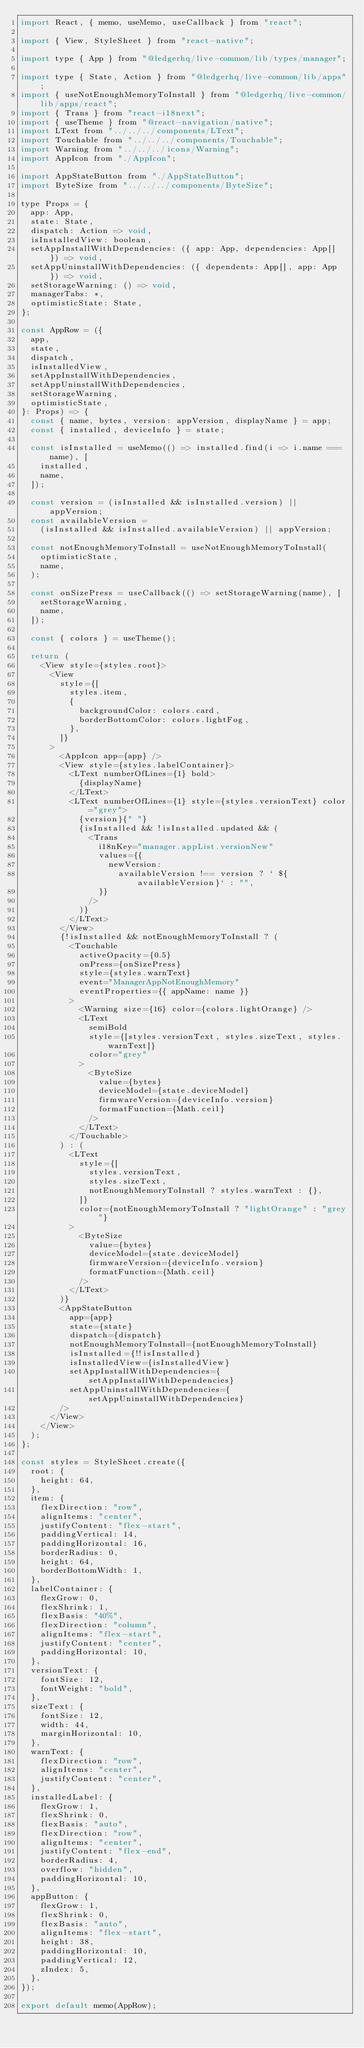Convert code to text. <code><loc_0><loc_0><loc_500><loc_500><_JavaScript_>import React, { memo, useMemo, useCallback } from "react";

import { View, StyleSheet } from "react-native";

import type { App } from "@ledgerhq/live-common/lib/types/manager";

import type { State, Action } from "@ledgerhq/live-common/lib/apps";
import { useNotEnoughMemoryToInstall } from "@ledgerhq/live-common/lib/apps/react";
import { Trans } from "react-i18next";
import { useTheme } from "@react-navigation/native";
import LText from "../../../components/LText";
import Touchable from "../../../components/Touchable";
import Warning from "../../../icons/Warning";
import AppIcon from "./AppIcon";

import AppStateButton from "./AppStateButton";
import ByteSize from "../../../components/ByteSize";

type Props = {
  app: App,
  state: State,
  dispatch: Action => void,
  isInstalledView: boolean,
  setAppInstallWithDependencies: ({ app: App, dependencies: App[] }) => void,
  setAppUninstallWithDependencies: ({ dependents: App[], app: App }) => void,
  setStorageWarning: () => void,
  managerTabs: *,
  optimisticState: State,
};

const AppRow = ({
  app,
  state,
  dispatch,
  isInstalledView,
  setAppInstallWithDependencies,
  setAppUninstallWithDependencies,
  setStorageWarning,
  optimisticState,
}: Props) => {
  const { name, bytes, version: appVersion, displayName } = app;
  const { installed, deviceInfo } = state;

  const isInstalled = useMemo(() => installed.find(i => i.name === name), [
    installed,
    name,
  ]);

  const version = (isInstalled && isInstalled.version) || appVersion;
  const availableVersion =
    (isInstalled && isInstalled.availableVersion) || appVersion;

  const notEnoughMemoryToInstall = useNotEnoughMemoryToInstall(
    optimisticState,
    name,
  );

  const onSizePress = useCallback(() => setStorageWarning(name), [
    setStorageWarning,
    name,
  ]);

  const { colors } = useTheme();

  return (
    <View style={styles.root}>
      <View
        style={[
          styles.item,
          {
            backgroundColor: colors.card,
            borderBottomColor: colors.lightFog,
          },
        ]}
      >
        <AppIcon app={app} />
        <View style={styles.labelContainer}>
          <LText numberOfLines={1} bold>
            {displayName}
          </LText>
          <LText numberOfLines={1} style={styles.versionText} color="grey">
            {version}{" "}
            {isInstalled && !isInstalled.updated && (
              <Trans
                i18nKey="manager.appList.versionNew"
                values={{
                  newVersion:
                    availableVersion !== version ? ` ${availableVersion}` : "",
                }}
              />
            )}
          </LText>
        </View>
        {!isInstalled && notEnoughMemoryToInstall ? (
          <Touchable
            activeOpacity={0.5}
            onPress={onSizePress}
            style={styles.warnText}
            event="ManagerAppNotEnoughMemory"
            eventProperties={{ appName: name }}
          >
            <Warning size={16} color={colors.lightOrange} />
            <LText
              semiBold
              style={[styles.versionText, styles.sizeText, styles.warnText]}
              color="grey"
            >
              <ByteSize
                value={bytes}
                deviceModel={state.deviceModel}
                firmwareVersion={deviceInfo.version}
                formatFunction={Math.ceil}
              />
            </LText>
          </Touchable>
        ) : (
          <LText
            style={[
              styles.versionText,
              styles.sizeText,
              notEnoughMemoryToInstall ? styles.warnText : {},
            ]}
            color={notEnoughMemoryToInstall ? "lightOrange" : "grey"}
          >
            <ByteSize
              value={bytes}
              deviceModel={state.deviceModel}
              firmwareVersion={deviceInfo.version}
              formatFunction={Math.ceil}
            />
          </LText>
        )}
        <AppStateButton
          app={app}
          state={state}
          dispatch={dispatch}
          notEnoughMemoryToInstall={notEnoughMemoryToInstall}
          isInstalled={!!isInstalled}
          isInstalledView={isInstalledView}
          setAppInstallWithDependencies={setAppInstallWithDependencies}
          setAppUninstallWithDependencies={setAppUninstallWithDependencies}
        />
      </View>
    </View>
  );
};

const styles = StyleSheet.create({
  root: {
    height: 64,
  },
  item: {
    flexDirection: "row",
    alignItems: "center",
    justifyContent: "flex-start",
    paddingVertical: 14,
    paddingHorizontal: 16,
    borderRadius: 0,
    height: 64,
    borderBottomWidth: 1,
  },
  labelContainer: {
    flexGrow: 0,
    flexShrink: 1,
    flexBasis: "40%",
    flexDirection: "column",
    alignItems: "flex-start",
    justifyContent: "center",
    paddingHorizontal: 10,
  },
  versionText: {
    fontSize: 12,
    fontWeight: "bold",
  },
  sizeText: {
    fontSize: 12,
    width: 44,
    marginHorizontal: 10,
  },
  warnText: {
    flexDirection: "row",
    alignItems: "center",
    justifyContent: "center",
  },
  installedLabel: {
    flexGrow: 1,
    flexShrink: 0,
    flexBasis: "auto",
    flexDirection: "row",
    alignItems: "center",
    justifyContent: "flex-end",
    borderRadius: 4,
    overflow: "hidden",
    paddingHorizontal: 10,
  },
  appButton: {
    flexGrow: 1,
    flexShrink: 0,
    flexBasis: "auto",
    alignItems: "flex-start",
    height: 38,
    paddingHorizontal: 10,
    paddingVertical: 12,
    zIndex: 5,
  },
});

export default memo(AppRow);
</code> 